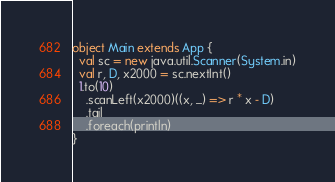Convert code to text. <code><loc_0><loc_0><loc_500><loc_500><_Scala_>object Main extends App {
  val sc = new java.util.Scanner(System.in)
  val r, D, x2000 = sc.nextInt()
  1.to(10)
    .scanLeft(x2000)((x, _) => r * x - D)
    .tail
    .foreach(println)
}
</code> 